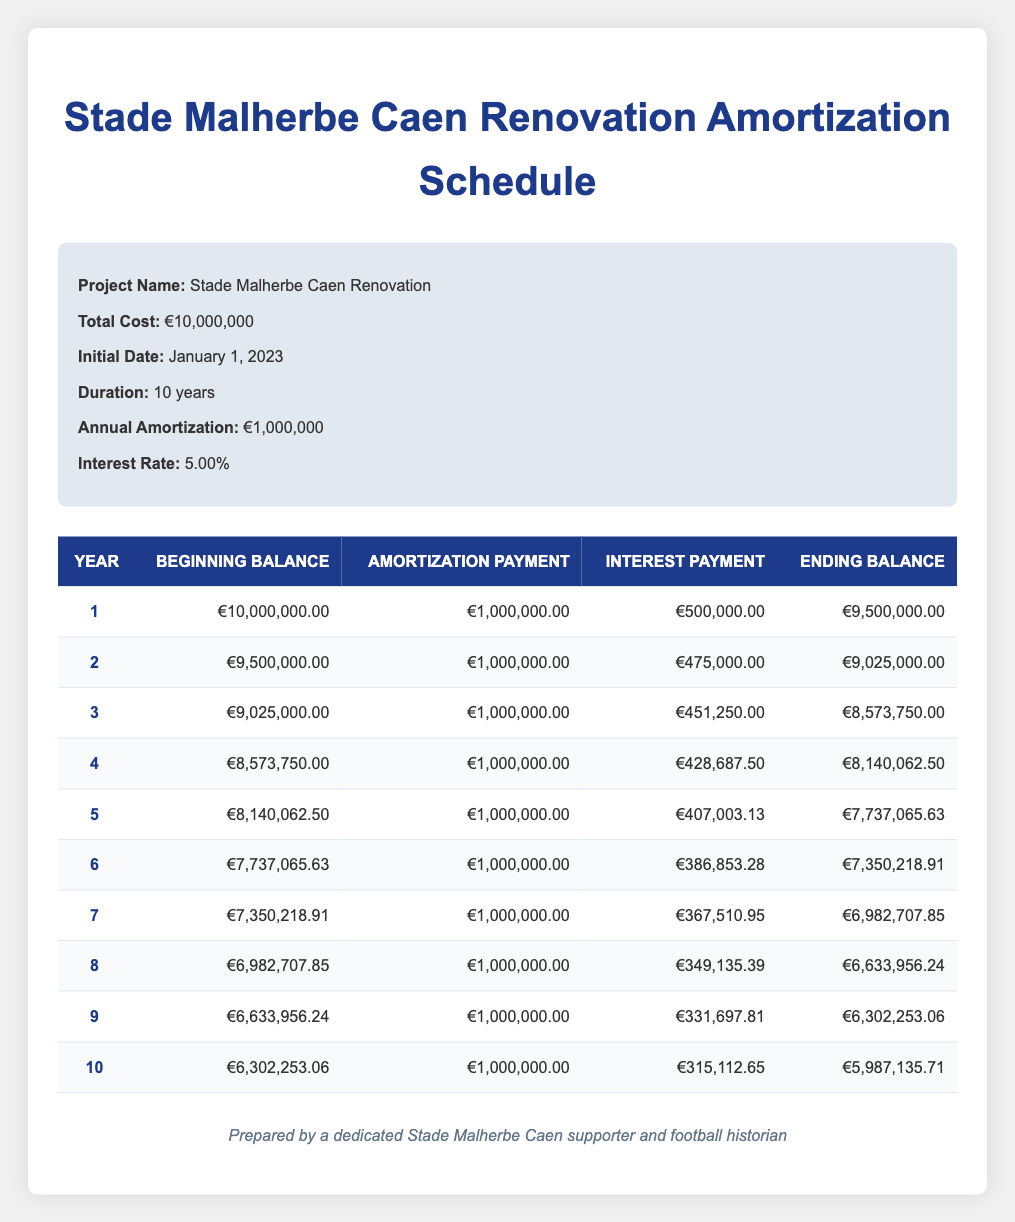What is the total cost for the Stade Malherbe Caen renovation project? The total cost is explicitly listed in the project information section as €10,000,000.
Answer: €10,000,000 How much is the annual amortization payment? The annual amortization payment is presented in the project information section, which states it is €1,000,000.
Answer: €1,000,000 What is the ending balance at the end of year 5? In the amortization table, the ending balance for year 5 is listed as €7,737,065.63.
Answer: €7,737,065.63 What is the sum of interest payments for the first three years? The interest payments for the first three years are €500,000, €475,000, and €451,250. Adding these amounts gives €500,000 + €475,000 + €451,250 = €1,426,250.
Answer: €1,426,250 Is the interest payment for year 2 higher than that for year 3? The interest payment for year 2 is €475,000, while for year 3 it is €451,250. Since €475,000 is greater than €451,250, the statement is true.
Answer: Yes What is the average ending balance from years 6 to 10? The ending balances for years 6 to 10 are €7,350,218.91, €6,982,707.85, €6,633,956.24, €6,302,253.06, and €5,987,135.71. To find the average, sum these values and divide by 5: (7,350,218.91 + 6,982,707.85 + 6,633,956.24 + 6,302,253.06 + 5,987,135.71) = 38,256,271.77, which divided by 5 equals approximately €7,651,254.35.
Answer: €7,651,254.35 In which year is the amortization payment equal to the interest payment? By inspecting the table, the amortization payment is consistently €1,000,000 and is always higher than the interest payments listed for each year, meaning there is no year where they are equal.
Answer: No year What is the reduction in the ending balance from year 1 to year 10? The ending balance in year 1 is €9,500,000, and in year 10 it is €5,987,135.71. The reduction is calculated as €9,500,000 - €5,987,135.71 = €3,512,864.29.
Answer: €3,512,864.29 How much total amortization will have been paid by the end of year 10? Since the annual amortization is €1,000,000 and it is paid over 10 years, the total amortization by year 10 would be €1,000,000 x 10 = €10,000,000.
Answer: €10,000,000 